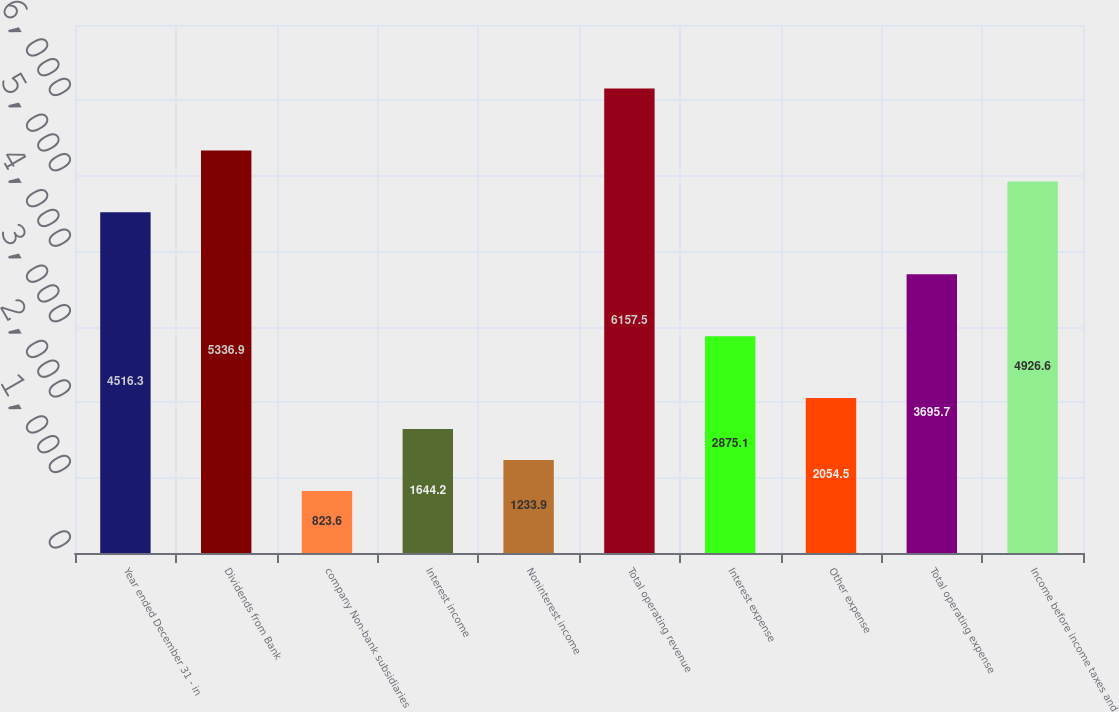Convert chart to OTSL. <chart><loc_0><loc_0><loc_500><loc_500><bar_chart><fcel>Year ended December 31 - in<fcel>Dividends from Bank<fcel>company Non-bank subsidiaries<fcel>Interest income<fcel>Noninterest income<fcel>Total operating revenue<fcel>Interest expense<fcel>Other expense<fcel>Total operating expense<fcel>Income before income taxes and<nl><fcel>4516.3<fcel>5336.9<fcel>823.6<fcel>1644.2<fcel>1233.9<fcel>6157.5<fcel>2875.1<fcel>2054.5<fcel>3695.7<fcel>4926.6<nl></chart> 